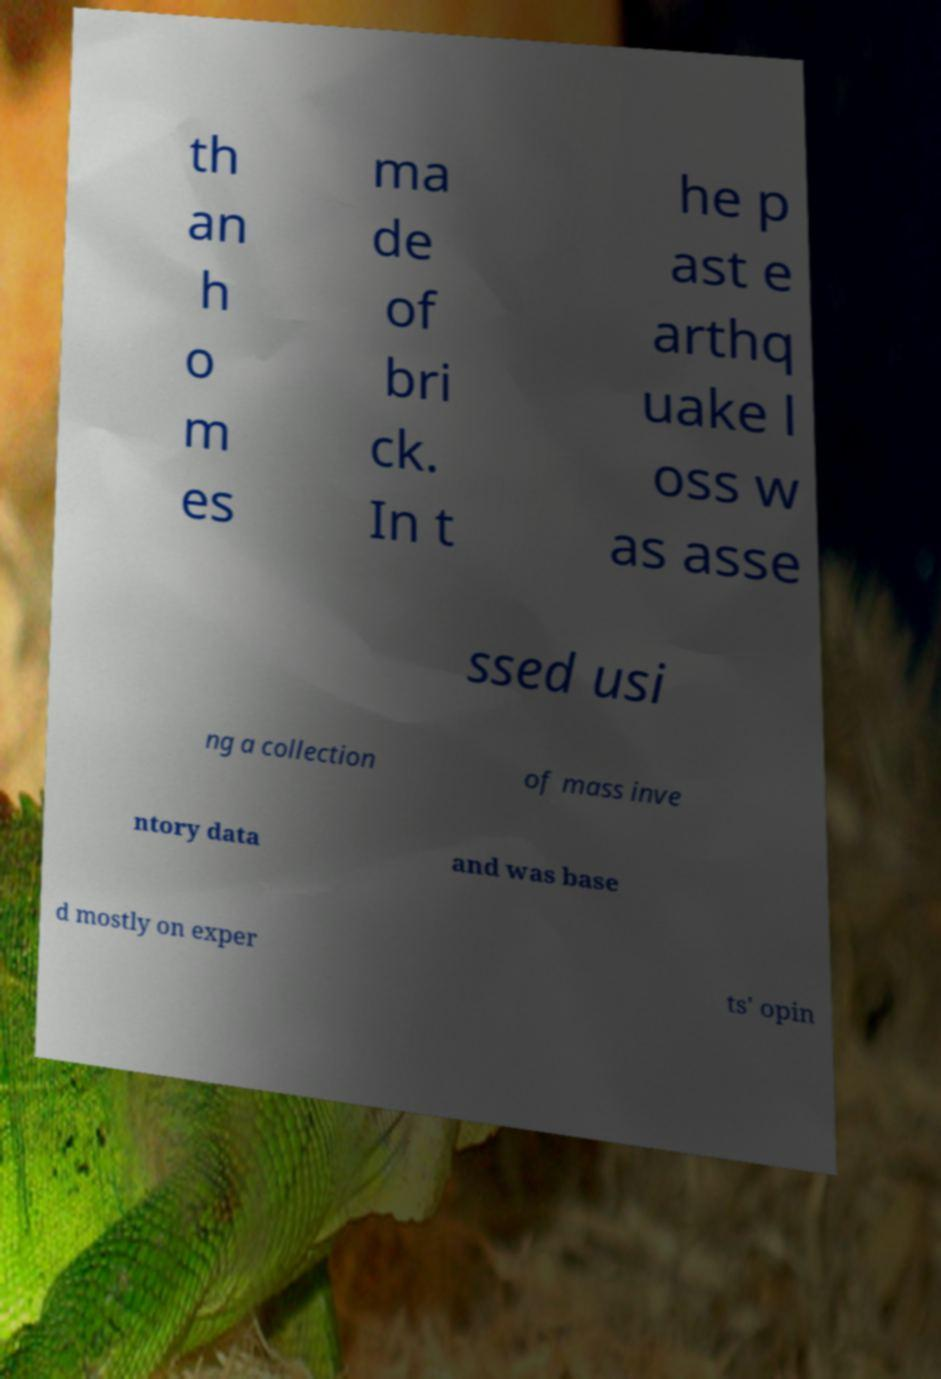What messages or text are displayed in this image? I need them in a readable, typed format. th an h o m es ma de of bri ck. In t he p ast e arthq uake l oss w as asse ssed usi ng a collection of mass inve ntory data and was base d mostly on exper ts' opin 